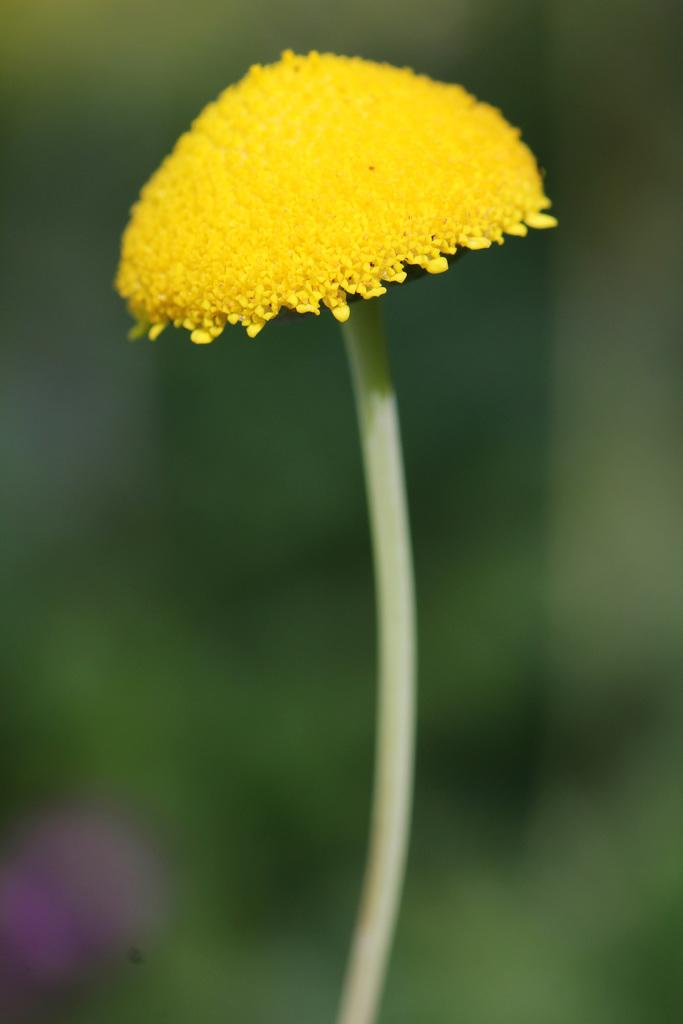What type of flower is in the image? There is a yellow color flower in the image. Can you describe the background of the image? The background of the image is blurred. What route does the cook take to prepare the flower in the image? There is no cook or preparation of the flower in the image; it is a static image of a yellow flower. 